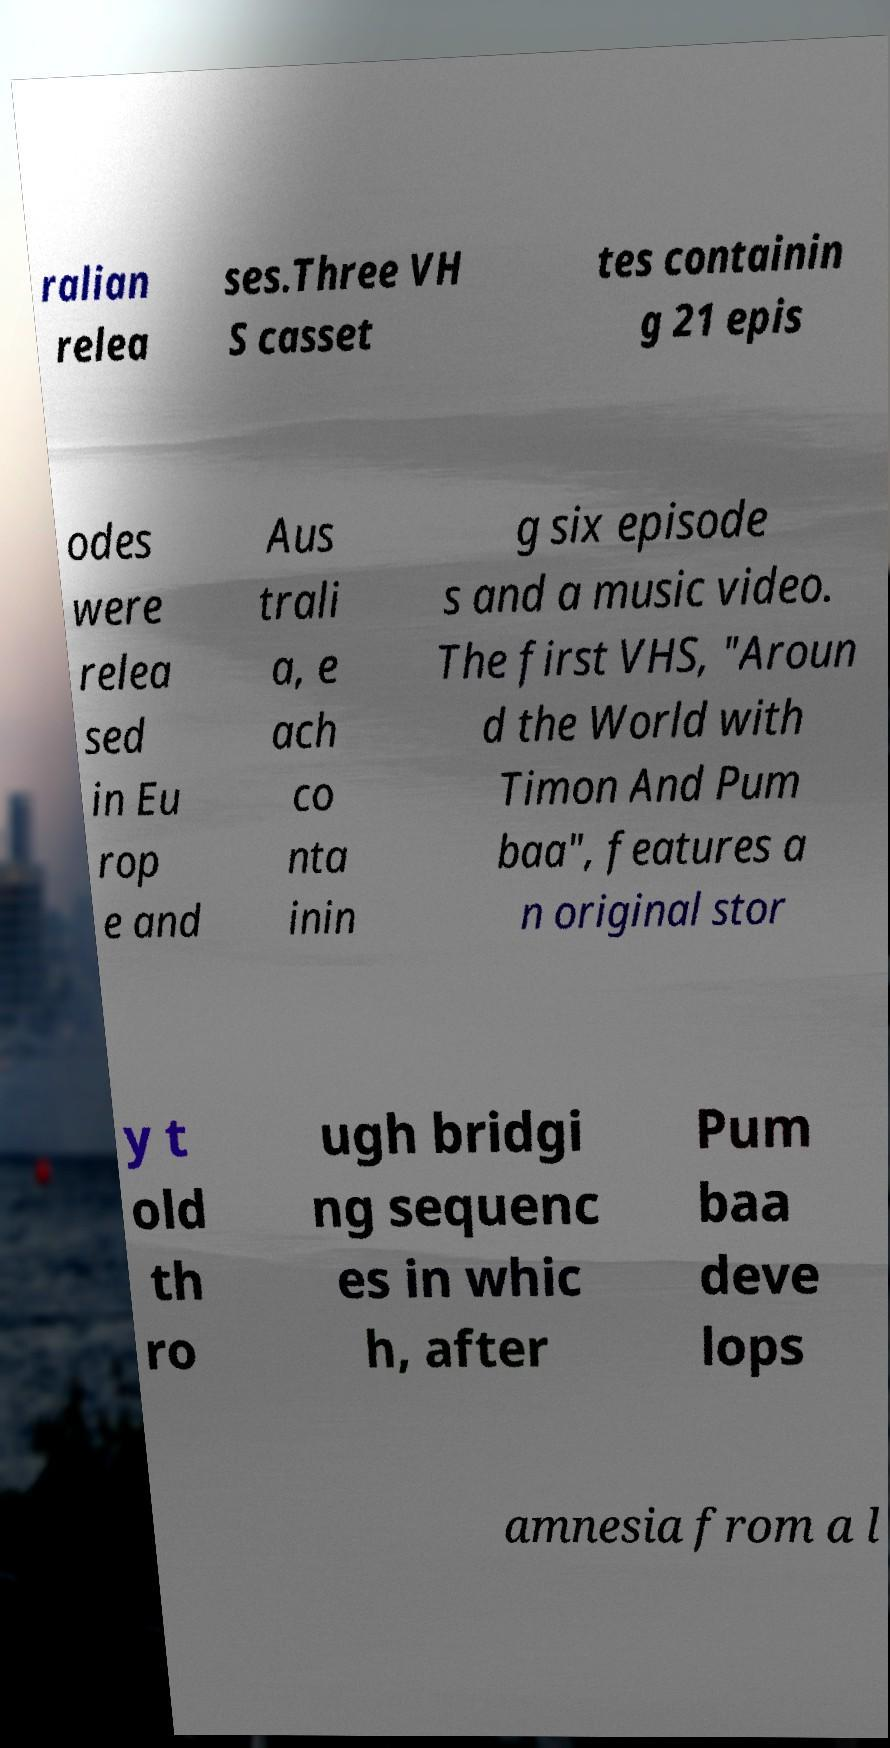What messages or text are displayed in this image? I need them in a readable, typed format. ralian relea ses.Three VH S casset tes containin g 21 epis odes were relea sed in Eu rop e and Aus trali a, e ach co nta inin g six episode s and a music video. The first VHS, "Aroun d the World with Timon And Pum baa", features a n original stor y t old th ro ugh bridgi ng sequenc es in whic h, after Pum baa deve lops amnesia from a l 